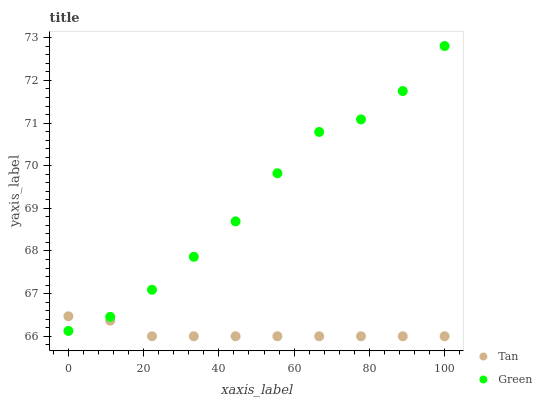Does Tan have the minimum area under the curve?
Answer yes or no. Yes. Does Green have the maximum area under the curve?
Answer yes or no. Yes. Does Green have the minimum area under the curve?
Answer yes or no. No. Is Tan the smoothest?
Answer yes or no. Yes. Is Green the roughest?
Answer yes or no. Yes. Is Green the smoothest?
Answer yes or no. No. Does Tan have the lowest value?
Answer yes or no. Yes. Does Green have the lowest value?
Answer yes or no. No. Does Green have the highest value?
Answer yes or no. Yes. Does Tan intersect Green?
Answer yes or no. Yes. Is Tan less than Green?
Answer yes or no. No. Is Tan greater than Green?
Answer yes or no. No. 